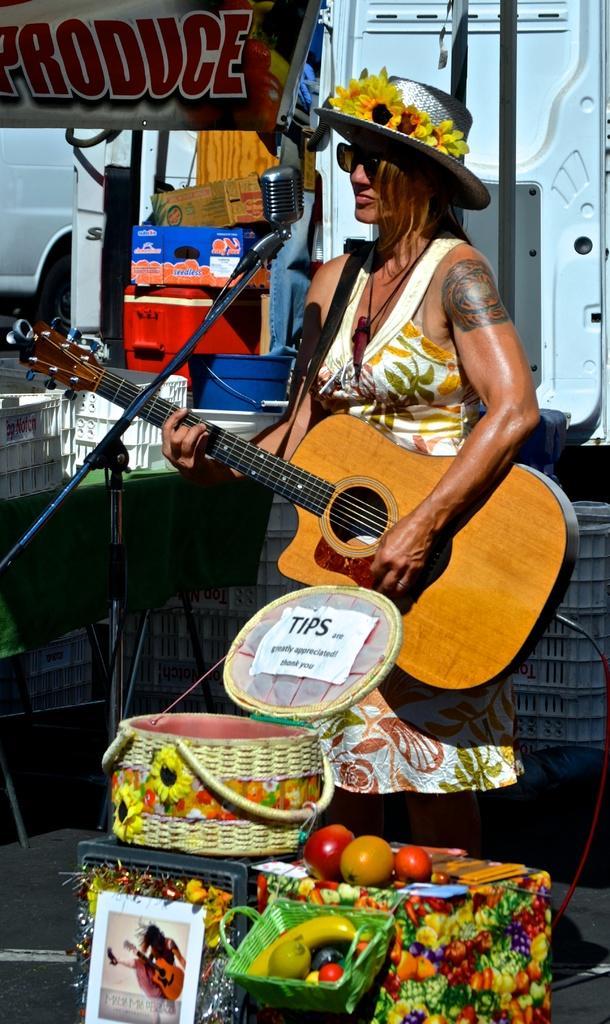Can you describe this image briefly? In the image we can see there is a woman who is holding a guitar in her hand and in front of her there are baskets which are filled with fruits. 